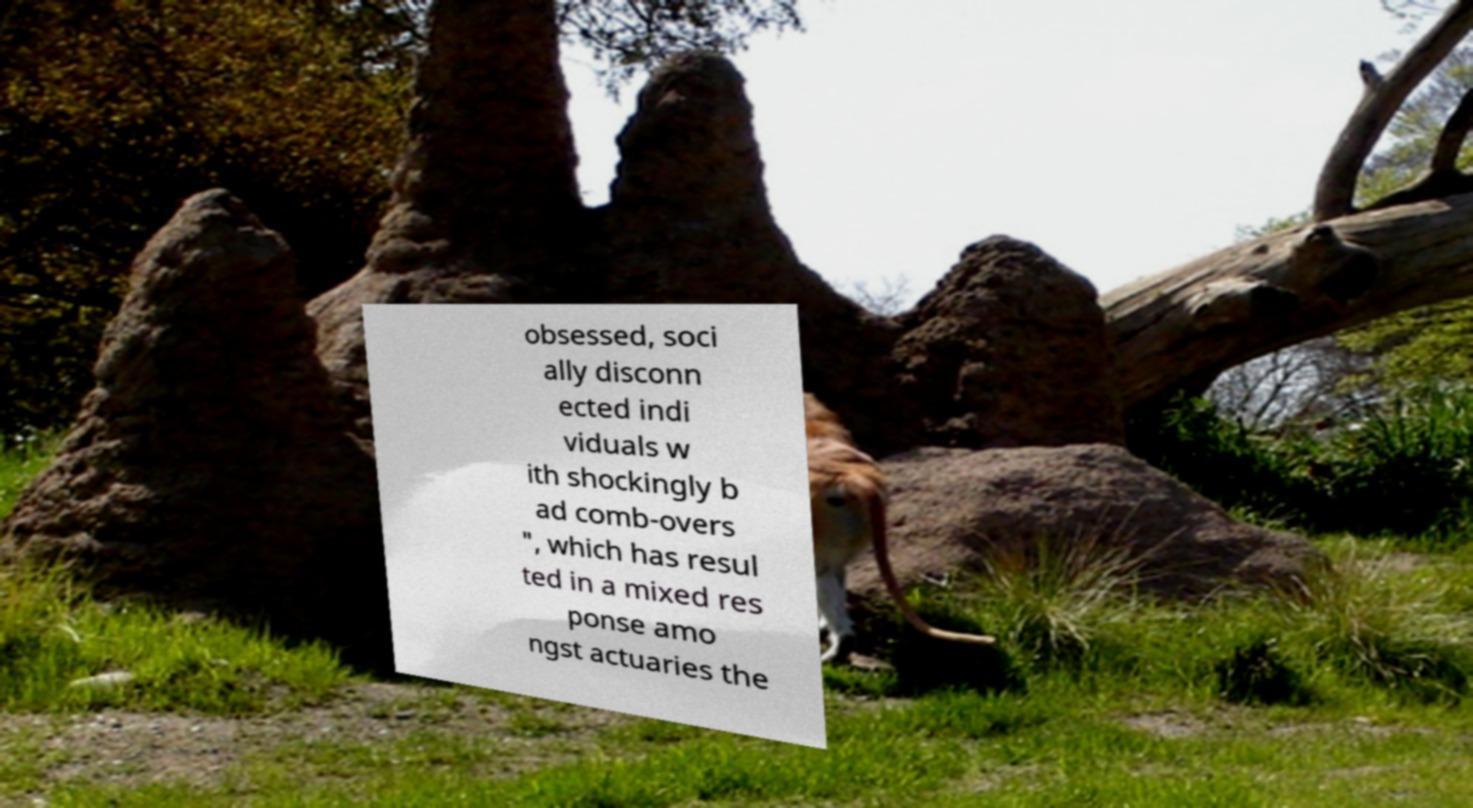There's text embedded in this image that I need extracted. Can you transcribe it verbatim? obsessed, soci ally disconn ected indi viduals w ith shockingly b ad comb-overs ", which has resul ted in a mixed res ponse amo ngst actuaries the 